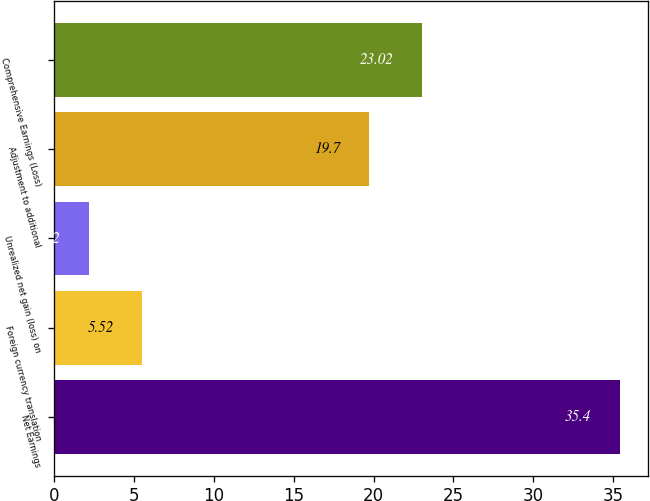Convert chart. <chart><loc_0><loc_0><loc_500><loc_500><bar_chart><fcel>Net Earnings<fcel>Foreign currency translation<fcel>Unrealized net gain (loss) on<fcel>Adjustment to additional<fcel>Comprehensive Earnings (Loss)<nl><fcel>35.4<fcel>5.52<fcel>2.2<fcel>19.7<fcel>23.02<nl></chart> 